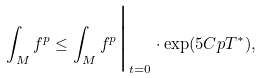<formula> <loc_0><loc_0><loc_500><loc_500>\int _ { M } f ^ { p } \leq { \int _ { M } f ^ { p } } \Big | _ { t = 0 } \cdot \exp ( 5 C p T ^ { * } ) ,</formula> 